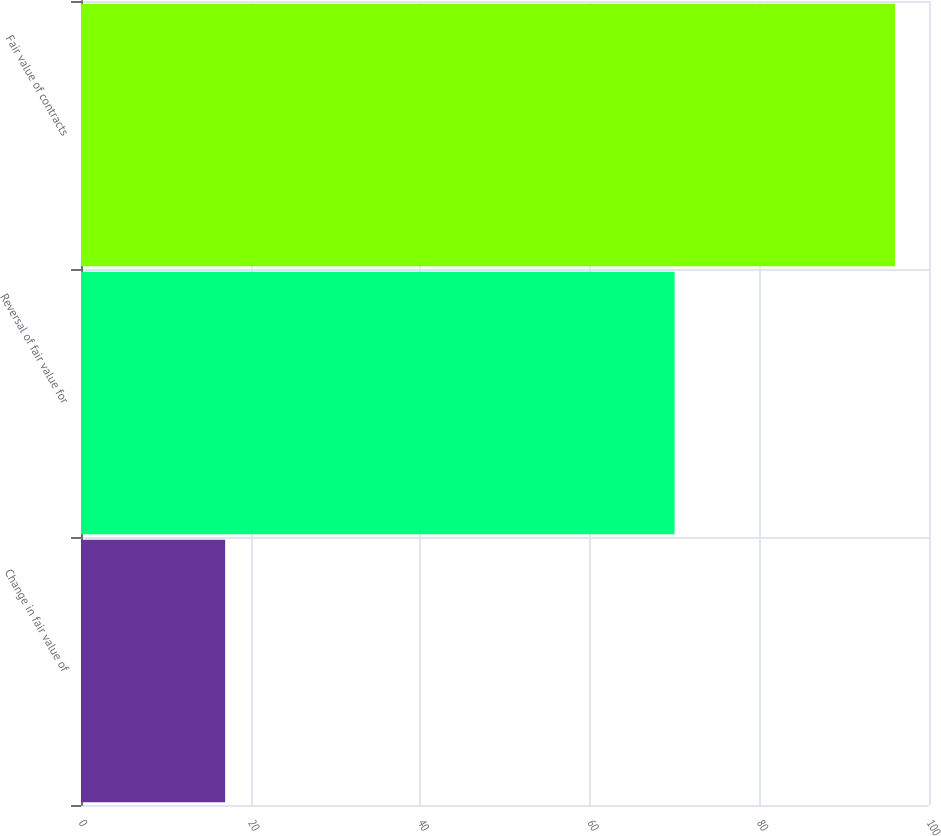Convert chart to OTSL. <chart><loc_0><loc_0><loc_500><loc_500><bar_chart><fcel>Change in fair value of<fcel>Reversal of fair value for<fcel>Fair value of contracts<nl><fcel>17<fcel>70<fcel>96<nl></chart> 